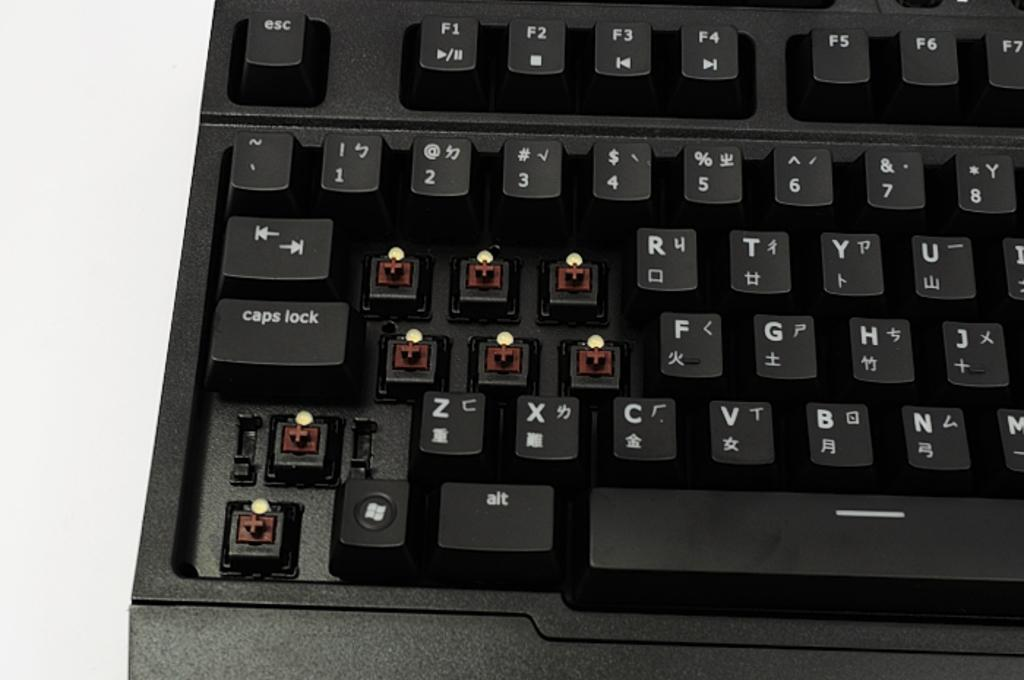Provide a one-sentence caption for the provided image. A black mechanical switch keyboard with the q,w,e,a,s,d, shift and ctrl key missing. 